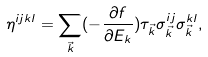<formula> <loc_0><loc_0><loc_500><loc_500>\eta ^ { i j k l } = \sum _ { \vec { k } } ( - \frac { \partial { f } } { \partial { E _ { k } } } ) \tau _ { \vec { k } } \sigma ^ { i j } _ { \vec { k } } \sigma ^ { k l } _ { \vec { k } } ,</formula> 